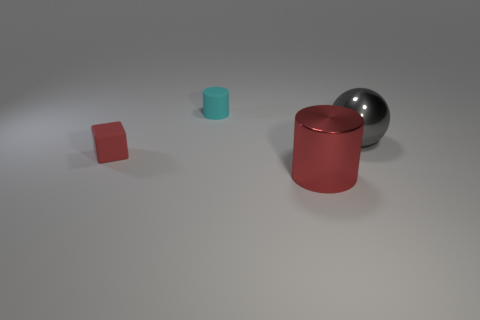Add 1 blocks. How many objects exist? 5 Subtract all blocks. How many objects are left? 3 Add 2 metal things. How many metal things are left? 4 Add 3 small yellow metal objects. How many small yellow metal objects exist? 3 Subtract 0 purple spheres. How many objects are left? 4 Subtract all red rubber cubes. Subtract all gray things. How many objects are left? 2 